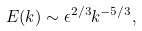Convert formula to latex. <formula><loc_0><loc_0><loc_500><loc_500>E ( k ) \sim \epsilon ^ { 2 / 3 } k ^ { - 5 / 3 } ,</formula> 